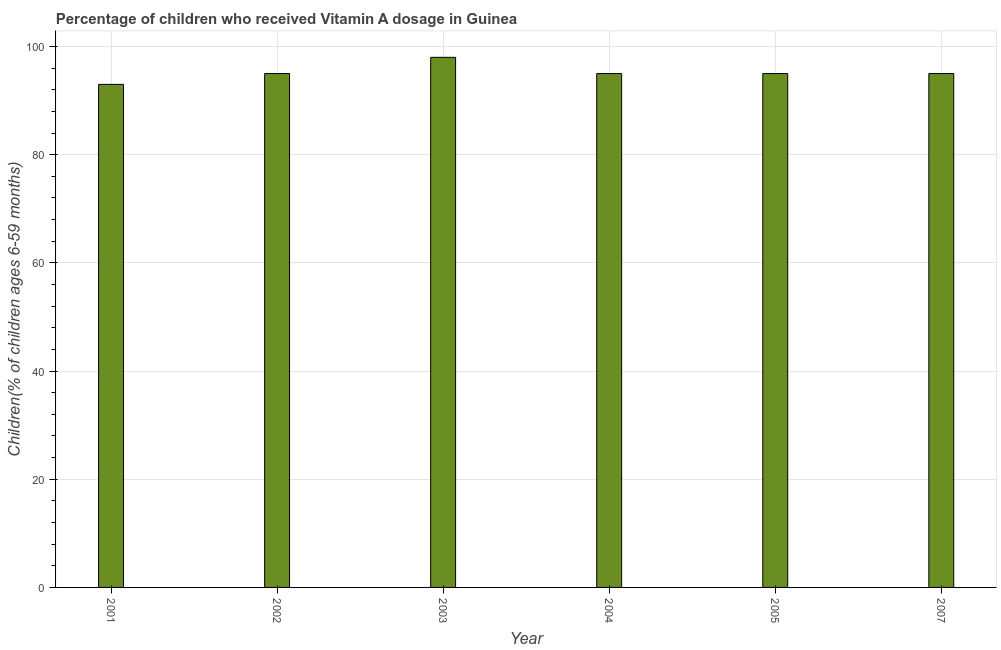What is the title of the graph?
Provide a succinct answer. Percentage of children who received Vitamin A dosage in Guinea. What is the label or title of the X-axis?
Offer a very short reply. Year. What is the label or title of the Y-axis?
Provide a short and direct response. Children(% of children ages 6-59 months). Across all years, what is the maximum vitamin a supplementation coverage rate?
Offer a terse response. 98. Across all years, what is the minimum vitamin a supplementation coverage rate?
Make the answer very short. 93. In which year was the vitamin a supplementation coverage rate minimum?
Your answer should be very brief. 2001. What is the sum of the vitamin a supplementation coverage rate?
Provide a short and direct response. 571. What is the average vitamin a supplementation coverage rate per year?
Keep it short and to the point. 95.17. What is the ratio of the vitamin a supplementation coverage rate in 2002 to that in 2003?
Offer a very short reply. 0.97. Is the difference between the vitamin a supplementation coverage rate in 2001 and 2007 greater than the difference between any two years?
Your answer should be very brief. No. What is the difference between the highest and the lowest vitamin a supplementation coverage rate?
Keep it short and to the point. 5. How many bars are there?
Your answer should be very brief. 6. How many years are there in the graph?
Your answer should be compact. 6. Are the values on the major ticks of Y-axis written in scientific E-notation?
Your answer should be very brief. No. What is the Children(% of children ages 6-59 months) of 2001?
Your response must be concise. 93. What is the Children(% of children ages 6-59 months) in 2002?
Offer a terse response. 95. What is the Children(% of children ages 6-59 months) in 2003?
Offer a terse response. 98. What is the difference between the Children(% of children ages 6-59 months) in 2001 and 2004?
Offer a terse response. -2. What is the difference between the Children(% of children ages 6-59 months) in 2001 and 2007?
Offer a very short reply. -2. What is the difference between the Children(% of children ages 6-59 months) in 2002 and 2003?
Provide a short and direct response. -3. What is the difference between the Children(% of children ages 6-59 months) in 2002 and 2005?
Give a very brief answer. 0. What is the difference between the Children(% of children ages 6-59 months) in 2002 and 2007?
Ensure brevity in your answer.  0. What is the difference between the Children(% of children ages 6-59 months) in 2004 and 2005?
Keep it short and to the point. 0. What is the difference between the Children(% of children ages 6-59 months) in 2005 and 2007?
Provide a short and direct response. 0. What is the ratio of the Children(% of children ages 6-59 months) in 2001 to that in 2002?
Keep it short and to the point. 0.98. What is the ratio of the Children(% of children ages 6-59 months) in 2001 to that in 2003?
Your answer should be very brief. 0.95. What is the ratio of the Children(% of children ages 6-59 months) in 2001 to that in 2004?
Ensure brevity in your answer.  0.98. What is the ratio of the Children(% of children ages 6-59 months) in 2001 to that in 2005?
Make the answer very short. 0.98. What is the ratio of the Children(% of children ages 6-59 months) in 2002 to that in 2003?
Your answer should be very brief. 0.97. What is the ratio of the Children(% of children ages 6-59 months) in 2002 to that in 2004?
Your answer should be very brief. 1. What is the ratio of the Children(% of children ages 6-59 months) in 2003 to that in 2004?
Give a very brief answer. 1.03. What is the ratio of the Children(% of children ages 6-59 months) in 2003 to that in 2005?
Ensure brevity in your answer.  1.03. What is the ratio of the Children(% of children ages 6-59 months) in 2003 to that in 2007?
Keep it short and to the point. 1.03. What is the ratio of the Children(% of children ages 6-59 months) in 2004 to that in 2005?
Ensure brevity in your answer.  1. What is the ratio of the Children(% of children ages 6-59 months) in 2004 to that in 2007?
Your response must be concise. 1. What is the ratio of the Children(% of children ages 6-59 months) in 2005 to that in 2007?
Keep it short and to the point. 1. 